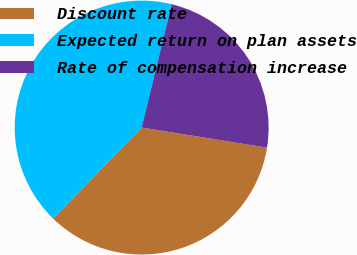Convert chart to OTSL. <chart><loc_0><loc_0><loc_500><loc_500><pie_chart><fcel>Discount rate<fcel>Expected return on plan assets<fcel>Rate of compensation increase<nl><fcel>34.76%<fcel>41.51%<fcel>23.73%<nl></chart> 